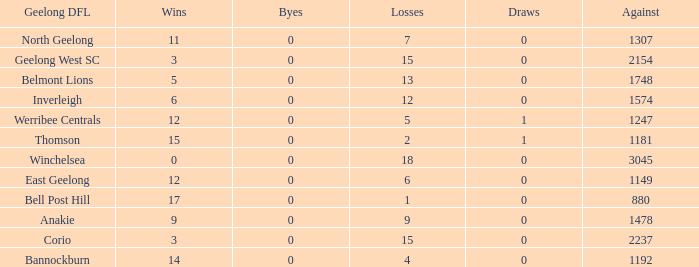What are the average losses for Geelong DFL of Bell Post Hill where the draws are less than 0? None. Parse the table in full. {'header': ['Geelong DFL', 'Wins', 'Byes', 'Losses', 'Draws', 'Against'], 'rows': [['North Geelong', '11', '0', '7', '0', '1307'], ['Geelong West SC', '3', '0', '15', '0', '2154'], ['Belmont Lions', '5', '0', '13', '0', '1748'], ['Inverleigh', '6', '0', '12', '0', '1574'], ['Werribee Centrals', '12', '0', '5', '1', '1247'], ['Thomson', '15', '0', '2', '1', '1181'], ['Winchelsea', '0', '0', '18', '0', '3045'], ['East Geelong', '12', '0', '6', '0', '1149'], ['Bell Post Hill', '17', '0', '1', '0', '880'], ['Anakie', '9', '0', '9', '0', '1478'], ['Corio', '3', '0', '15', '0', '2237'], ['Bannockburn', '14', '0', '4', '0', '1192']]} 